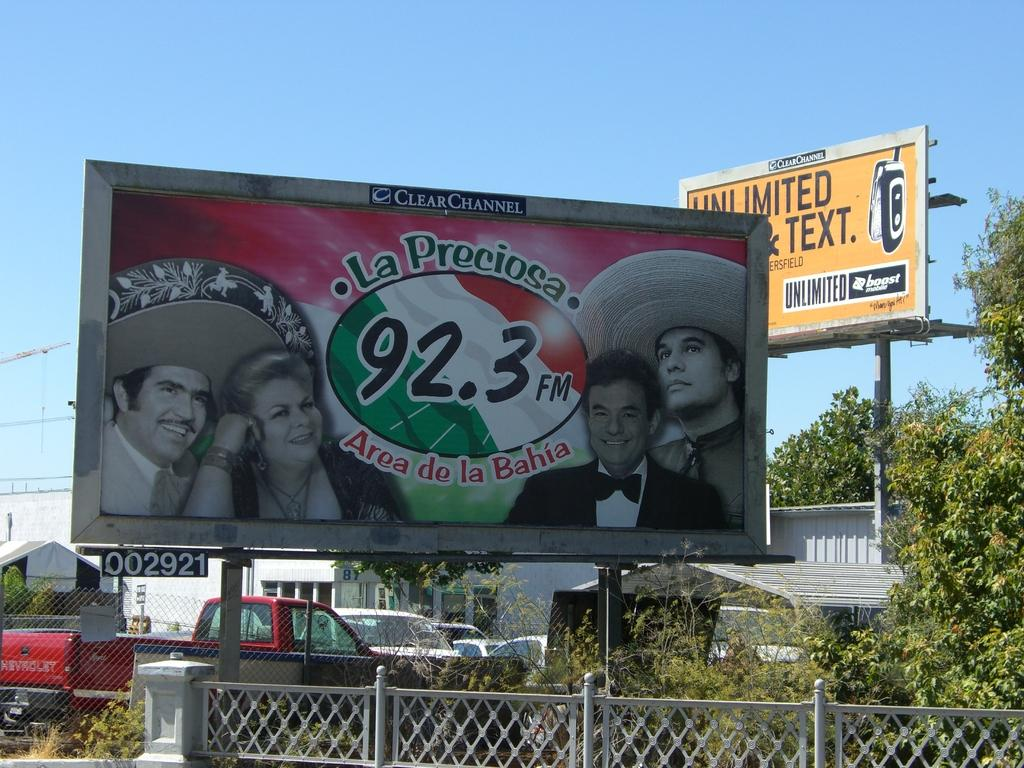<image>
Write a terse but informative summary of the picture. A billboard advertises the radio station LA Preciosa, 92.3 FM, Area de la Baja with another billboard for unlimited talk and text in the background. 